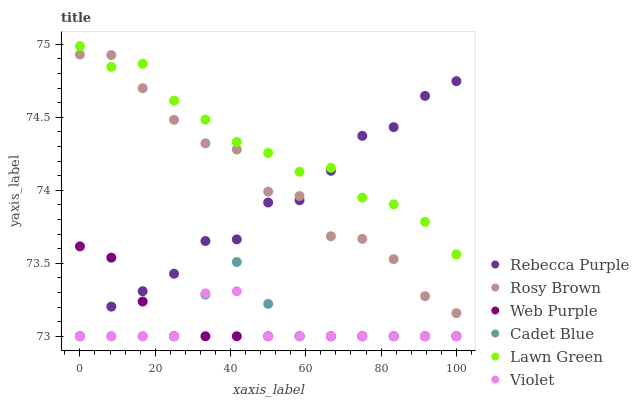Does Violet have the minimum area under the curve?
Answer yes or no. Yes. Does Lawn Green have the maximum area under the curve?
Answer yes or no. Yes. Does Cadet Blue have the minimum area under the curve?
Answer yes or no. No. Does Cadet Blue have the maximum area under the curve?
Answer yes or no. No. Is Web Purple the smoothest?
Answer yes or no. Yes. Is Rosy Brown the roughest?
Answer yes or no. Yes. Is Cadet Blue the smoothest?
Answer yes or no. No. Is Cadet Blue the roughest?
Answer yes or no. No. Does Cadet Blue have the lowest value?
Answer yes or no. Yes. Does Rosy Brown have the lowest value?
Answer yes or no. No. Does Lawn Green have the highest value?
Answer yes or no. Yes. Does Cadet Blue have the highest value?
Answer yes or no. No. Is Cadet Blue less than Lawn Green?
Answer yes or no. Yes. Is Rosy Brown greater than Web Purple?
Answer yes or no. Yes. Does Cadet Blue intersect Rebecca Purple?
Answer yes or no. Yes. Is Cadet Blue less than Rebecca Purple?
Answer yes or no. No. Is Cadet Blue greater than Rebecca Purple?
Answer yes or no. No. Does Cadet Blue intersect Lawn Green?
Answer yes or no. No. 